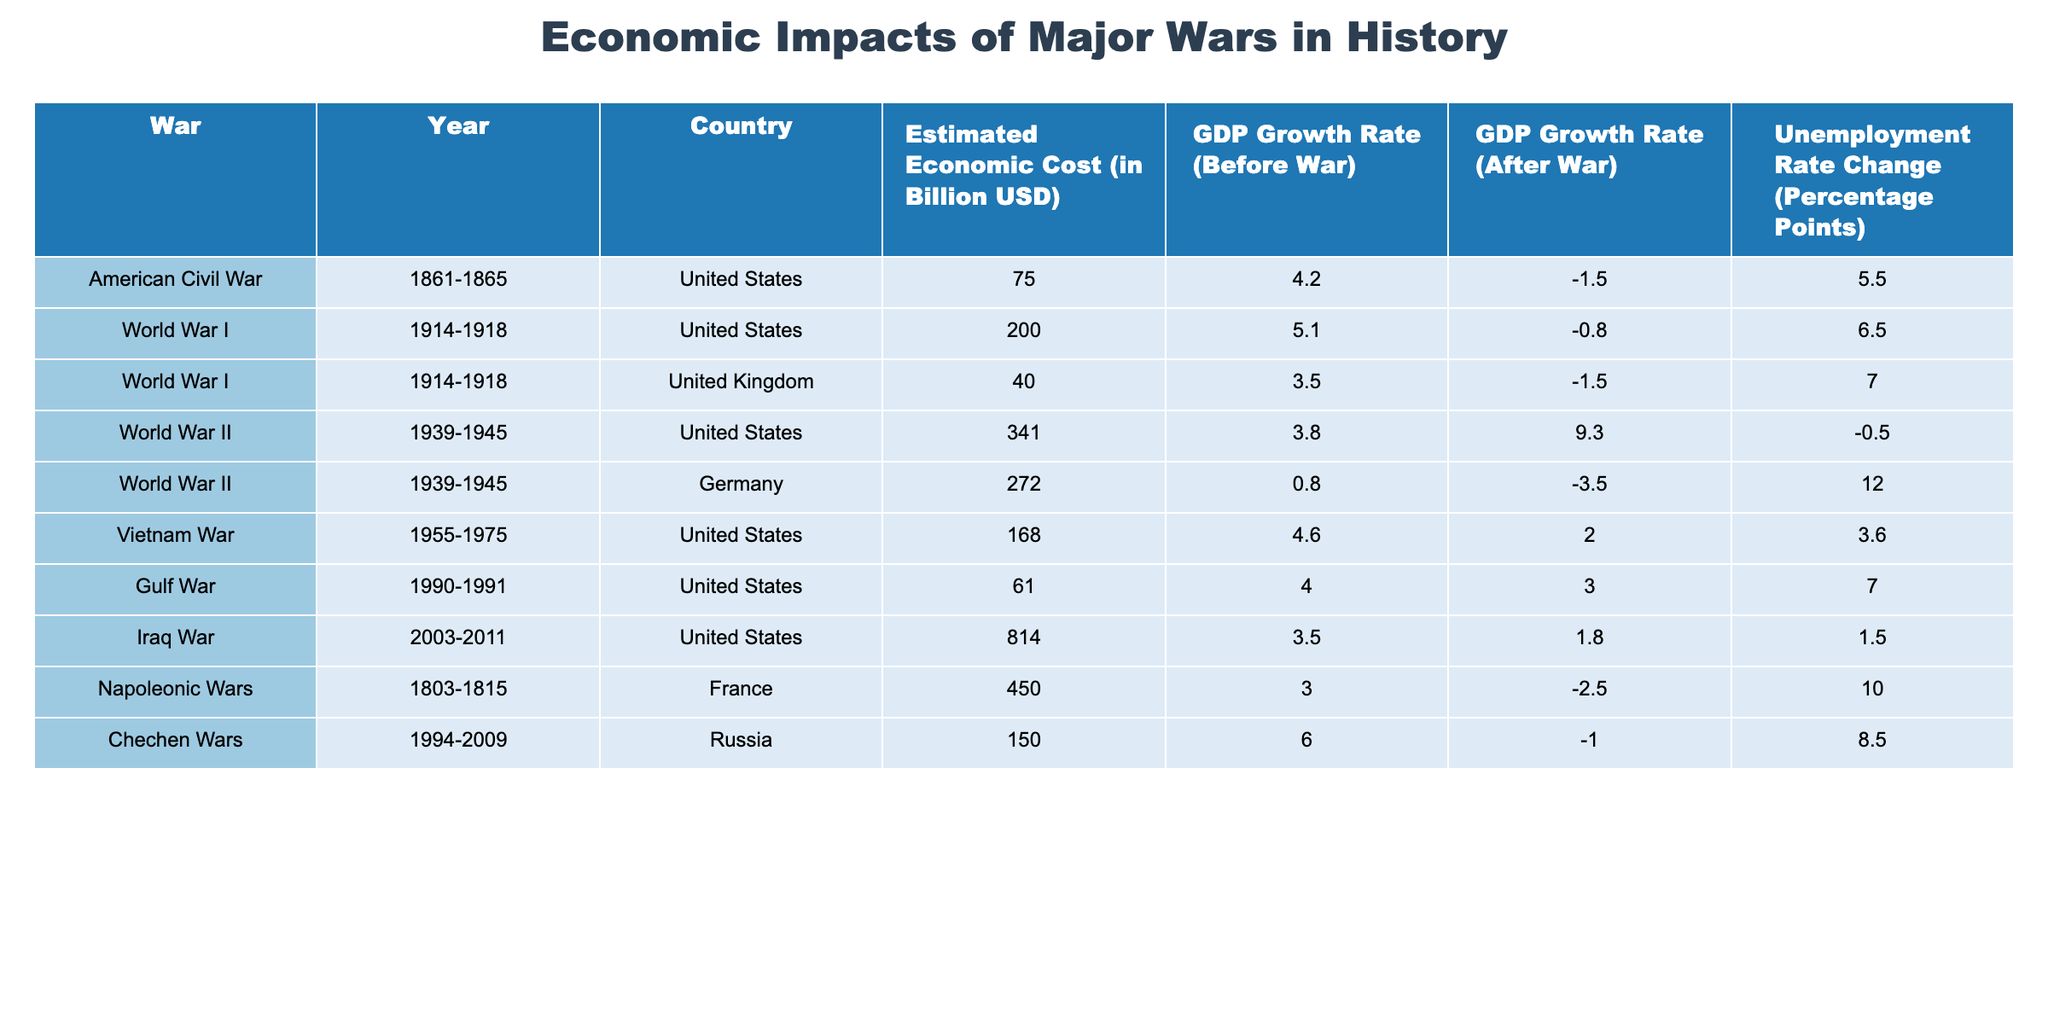What is the estimated economic cost of the American Civil War? The table indicates that the estimated economic cost of the American Civil War, listed under the "Estimated Economic Cost (in Billion USD)" column, is 75 billion.
Answer: 75 billion USD Which war had the highest estimated economic cost? By comparing the values in the "Estimated Economic Cost (in Billion USD)" column, World War II for the United States has the highest cost at 341 billion, followed by the Iraq War at 814 billion.
Answer: Iraq War with 814 billion USD What was the GDP growth rate of the United States after World War II? The "GDP Growth Rate (After War)" for the United States in World War II is found in the respective column and is 9.3%.
Answer: 9.3% Did the unemployment rate increase for the United Kingdom during World War I? The table shows the "Unemployment Rate Change (Percentage Points)" for the United Kingdom during World War I is 7.0%, which indicates an increase.
Answer: Yes What is the difference in GDP growth rate before and after the Vietnam War for the United States? The GDP growth rate before the Vietnam War is 4.6% and after is 2.0%. The difference is calculated as 4.6% - 2.0% = 2.6%.
Answer: 2.6% What is the average estimated economic cost of the wars listed for the United States? The costs for the United States wars are 75, 200, 341, 168, 61, and 814 billion. The sum is 1669 billion, and the average is calculated by dividing by 6, giving 1669/6 = 278.17.
Answer: 278.17 billion USD Was there a reduction in the GDP growth rate for Germany after World War II? The GDP growth rate for Germany before was 0.8% and after was -3.5%. Since the value decreased, it indicates a reduction.
Answer: Yes Which war had the most significant change in unemployment rate for Russia? The Chechen Wars show an "Unemployment Rate Change" of 8.5%. Comparing this to others, it is the largest change in the table.
Answer: Chechen Wars with 8.5% change What was the GDP growth rate before the Napoleonic Wars for France? The table states that the GDP growth rate before the Napoleonic Wars was 3.0%. This is confirmed in the "GDP Growth Rate (Before War)" column for France.
Answer: 3.0% Which war resulted in the largest unemployment rate change among the wars listed? Looking through the "Unemployment Rate Change (Percentage Points)" column, the Napoleonic Wars had a change of 10.0%, which is the largest.
Answer: Napoleonic Wars with 10.0% 